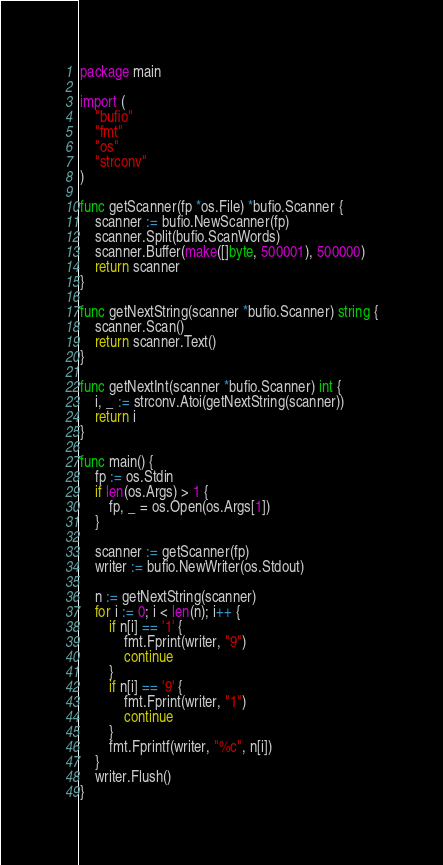Convert code to text. <code><loc_0><loc_0><loc_500><loc_500><_Go_>package main

import (
	"bufio"
	"fmt"
	"os"
	"strconv"
)

func getScanner(fp *os.File) *bufio.Scanner {
	scanner := bufio.NewScanner(fp)
	scanner.Split(bufio.ScanWords)
	scanner.Buffer(make([]byte, 500001), 500000)
	return scanner
}

func getNextString(scanner *bufio.Scanner) string {
	scanner.Scan()
	return scanner.Text()
}

func getNextInt(scanner *bufio.Scanner) int {
	i, _ := strconv.Atoi(getNextString(scanner))
	return i
}

func main() {
	fp := os.Stdin
	if len(os.Args) > 1 {
		fp, _ = os.Open(os.Args[1])
	}

	scanner := getScanner(fp)
	writer := bufio.NewWriter(os.Stdout)

	n := getNextString(scanner)
	for i := 0; i < len(n); i++ {
		if n[i] == '1' {
			fmt.Fprint(writer, "9")
			continue
		}
		if n[i] == '9' {
			fmt.Fprint(writer, "1")
			continue
		}
		fmt.Fprintf(writer, "%c", n[i])
	}
	writer.Flush()
}
</code> 